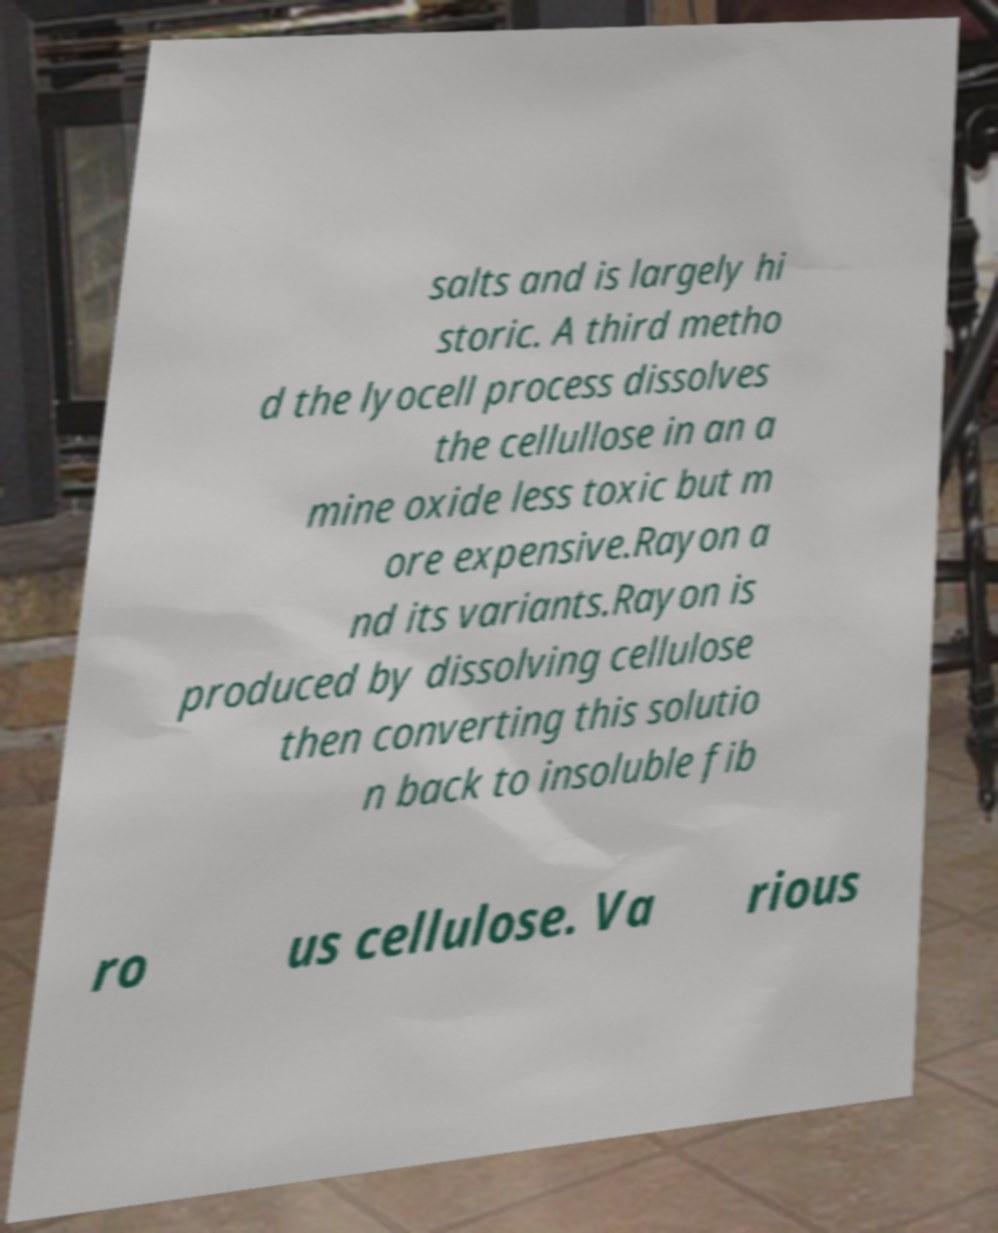I need the written content from this picture converted into text. Can you do that? salts and is largely hi storic. A third metho d the lyocell process dissolves the cellullose in an a mine oxide less toxic but m ore expensive.Rayon a nd its variants.Rayon is produced by dissolving cellulose then converting this solutio n back to insoluble fib ro us cellulose. Va rious 